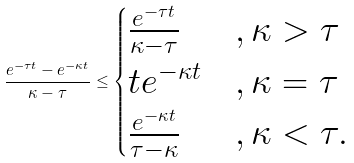Convert formula to latex. <formula><loc_0><loc_0><loc_500><loc_500>\frac { e ^ { - \tau t } - e ^ { - \kappa t } } { \kappa - \tau } \leq \begin{cases} \frac { e ^ { - \tau t } } { \kappa - \tau } & , \kappa > \tau \\ t e ^ { - \kappa t } & , \kappa = \tau \\ \frac { e ^ { - \kappa t } } { \tau - \kappa } & , \kappa < \tau . \end{cases}</formula> 